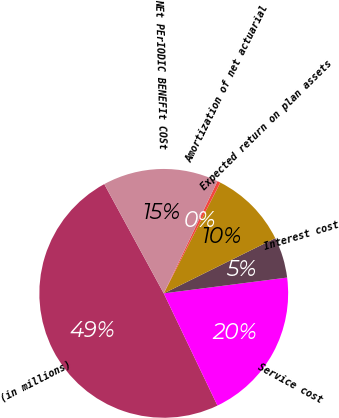<chart> <loc_0><loc_0><loc_500><loc_500><pie_chart><fcel>(in millions)<fcel>Service cost<fcel>Interest cost<fcel>Expected return on plan assets<fcel>Amortization of net actuarial<fcel>NEt PErIODIC BENEFIt COSt<nl><fcel>49.17%<fcel>19.92%<fcel>5.29%<fcel>10.17%<fcel>0.41%<fcel>15.04%<nl></chart> 